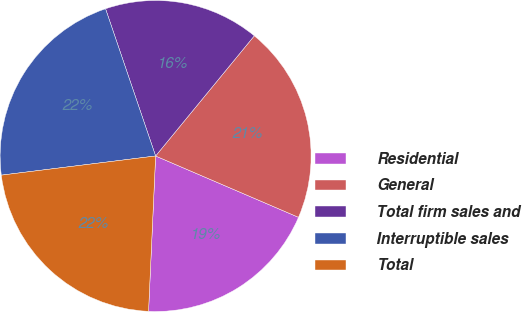<chart> <loc_0><loc_0><loc_500><loc_500><pie_chart><fcel>Residential<fcel>General<fcel>Total firm sales and<fcel>Interruptible sales<fcel>Total<nl><fcel>19.27%<fcel>20.51%<fcel>16.16%<fcel>21.75%<fcel>22.31%<nl></chart> 